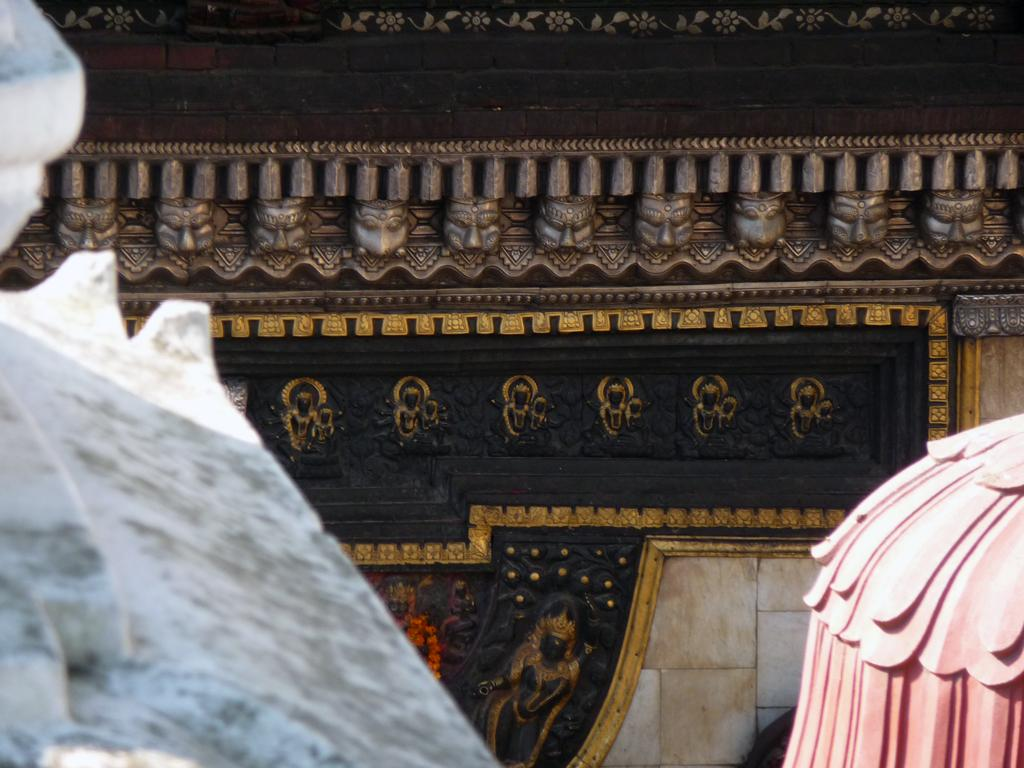What can be seen on the wall in the image? There are sculptures on the wall in the image. What else is present on the sides in the image? There are objects on the sides in the image. What type of plant is growing on the wall in the image? There is no plant growing on the wall in the image; it features sculptures on the wall. What effect does the route have on the objects on the sides in the image? There is no mention of a route in the image, so it is not possible to determine any effect it might have on the objects on the sides. 